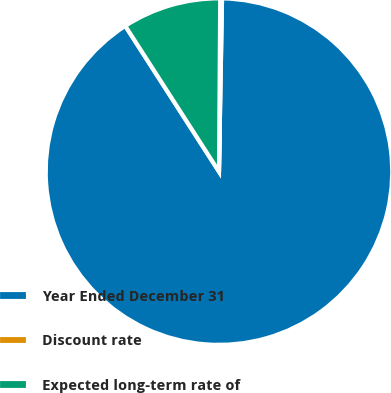<chart> <loc_0><loc_0><loc_500><loc_500><pie_chart><fcel>Year Ended December 31<fcel>Discount rate<fcel>Expected long-term rate of<nl><fcel>90.62%<fcel>0.17%<fcel>9.21%<nl></chart> 